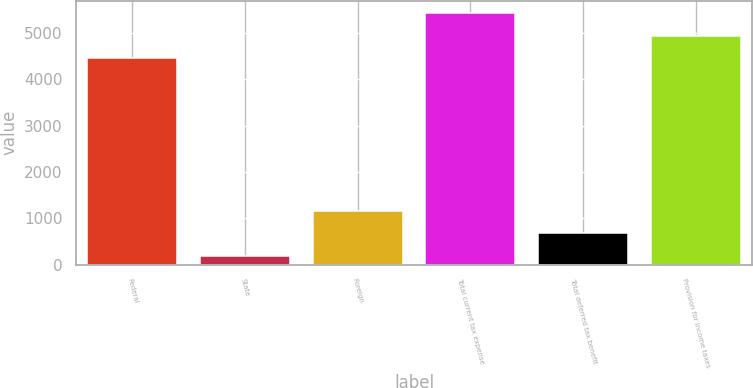Convert chart. <chart><loc_0><loc_0><loc_500><loc_500><bar_chart><fcel>Federal<fcel>State<fcel>Foreign<fcel>Total current tax expense<fcel>Total deferred tax benefit<fcel>Provision for income taxes<nl><fcel>4455<fcel>190<fcel>1158.8<fcel>5423.8<fcel>674.4<fcel>4939.4<nl></chart> 